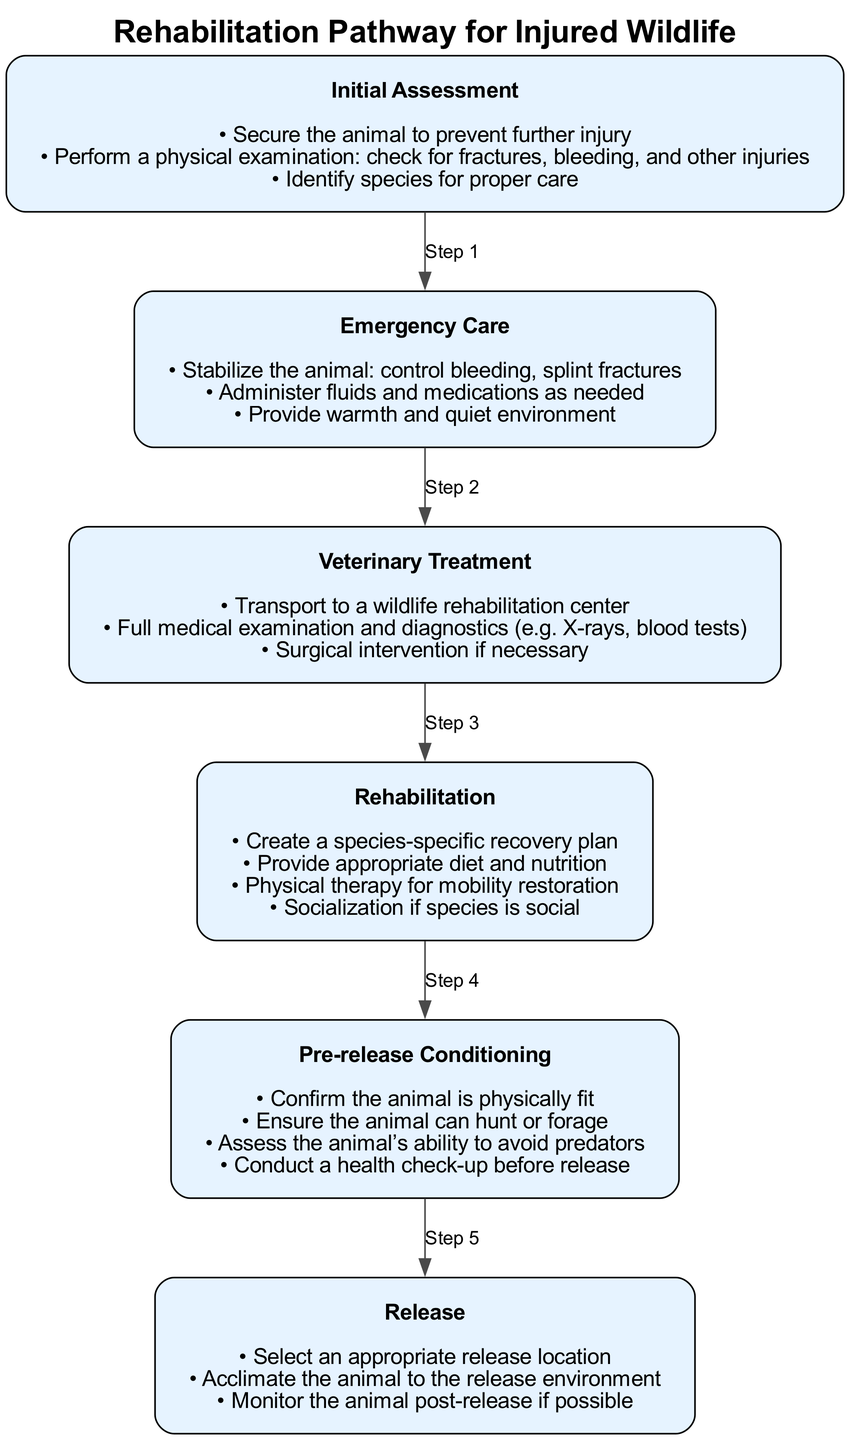What is the first step in the rehabilitation pathway? The first step listed in the diagram is "Initial Assessment". It is the topmost node that initiates the rehabilitation process for injured wildlife.
Answer: Initial Assessment How many steps are shown in the diagram? The diagram details a total of six distinct steps, each representing a critical stage in the rehabilitation pathway.
Answer: 6 Which step includes administering fluids and medications? The "Emergency Care" step contains the element of administering fluids and medications as a part of caring for the injured wildlife.
Answer: Emergency Care What is required before the release of the animal? Before the "Release" step, the diagram states that a health check-up is required to ensure the animal is fit for release. This is part of the "Pre-release Conditioning" process.
Answer: Health check-up Which step follows after "Veterinary Treatment"? The "Rehabilitation" step directly follows the "Veterinary Treatment". This shows the progression of care after medical treatment is given.
Answer: Rehabilitation What condition must be assessed before releasing an animal? The condition that must be assessed is the animal's ability to avoid predators, which is indicated in the "Pre-release Conditioning" step of the diagram.
Answer: Ability to avoid predators How many actions are listed under the "Rehabilitation" step? There are four actions outlined under the "Rehabilitation" step, focusing on creating a recovery plan, providing nutrition, physical therapy, and socialization.
Answer: 4 What is emphasized in the "Initial Assessment"? The "Initial Assessment" emphasizes securing the animal to prevent further injury, which is crucial in the very first moment of care.
Answer: Secure the animal What is included in the "Release" step? The "Release" step includes selecting an appropriate release location, which is key to ensuring the success of reintroducing the animal to the wild.
Answer: Select an appropriate release location 